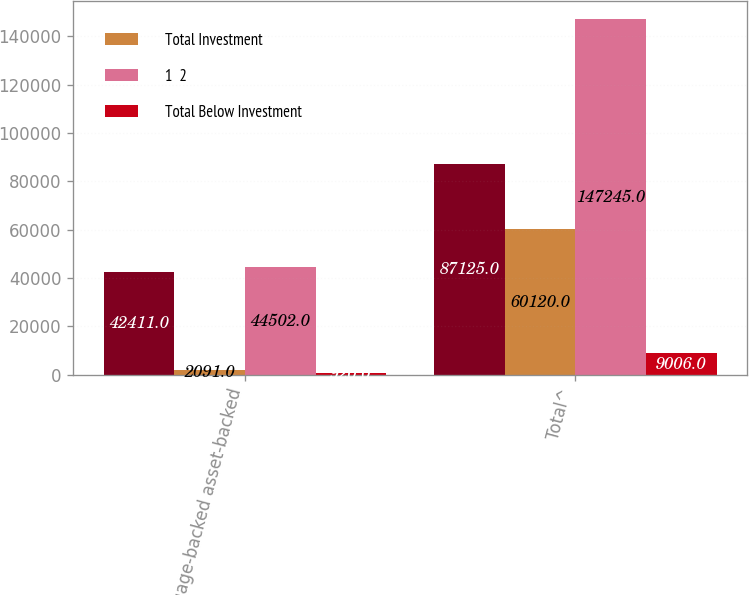<chart> <loc_0><loc_0><loc_500><loc_500><stacked_bar_chart><ecel><fcel>Mortgage-backed asset-backed<fcel>Total^<nl><fcel>nan<fcel>42411<fcel>87125<nl><fcel>Total Investment<fcel>2091<fcel>60120<nl><fcel>1  2<fcel>44502<fcel>147245<nl><fcel>Total Below Investment<fcel>920<fcel>9006<nl></chart> 